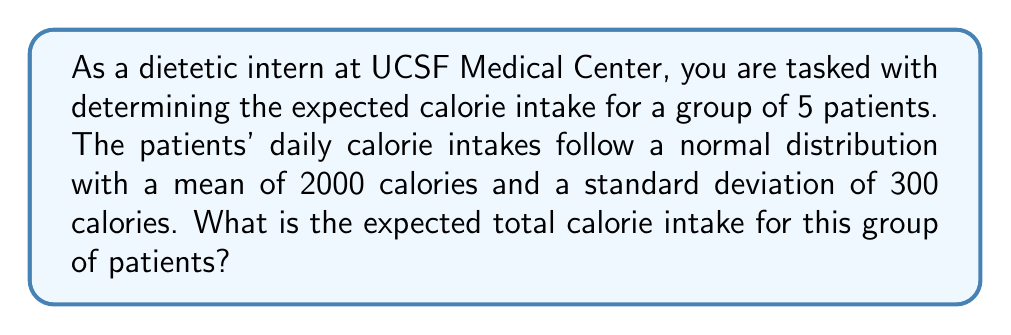Provide a solution to this math problem. Let's approach this step-by-step:

1) First, we need to understand what we're given:
   - There are 5 patients
   - Each patient's calorie intake follows a normal distribution
   - The mean (μ) of this distribution is 2000 calories
   - The standard deviation (σ) is 300 calories

2) The expected value of each patient's calorie intake is equal to the mean of the distribution:
   
   $E(X) = μ = 2000$ calories

3) We want to find the expected total calorie intake for all 5 patients. Let's call this total $Y$.
   
   $Y = X_1 + X_2 + X_3 + X_4 + X_5$

   where $X_i$ represents the calorie intake of the $i$-th patient.

4) A key property of expected values is linearity. This means:
   
   $E(Y) = E(X_1 + X_2 + X_3 + X_4 + X_5)$
   $= E(X_1) + E(X_2) + E(X_3) + E(X_4) + E(X_5)$

5) Since each $X_i$ has the same expected value (2000 calories), we can simplify this to:
   
   $E(Y) = 2000 + 2000 + 2000 + 2000 + 2000$
   $= 5 * 2000 = 10000$ calories

Therefore, the expected total calorie intake for the group of 5 patients is 10000 calories.
Answer: 10000 calories 